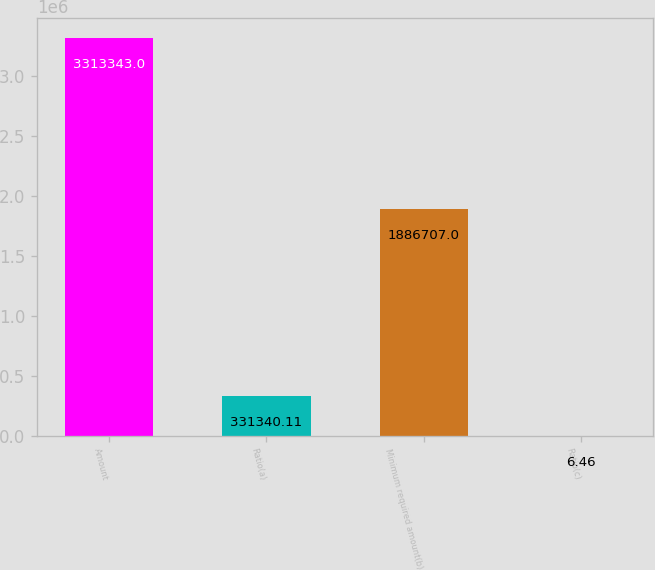Convert chart. <chart><loc_0><loc_0><loc_500><loc_500><bar_chart><fcel>Amount<fcel>Ratio(a)<fcel>Minimum required amount(b)<fcel>Ratio(c)<nl><fcel>3.31334e+06<fcel>331340<fcel>1.88671e+06<fcel>6.46<nl></chart> 